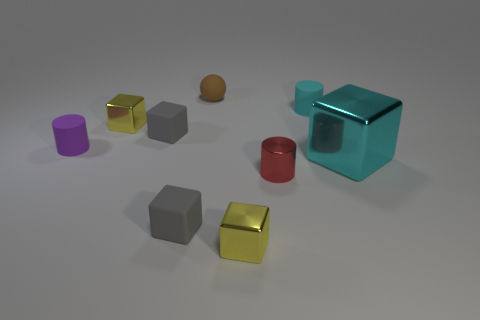Subtract all cyan blocks. How many blocks are left? 4 Subtract all cyan cubes. How many cubes are left? 4 Subtract all blue cubes. Subtract all yellow spheres. How many cubes are left? 5 Add 1 small green metallic things. How many objects exist? 10 Subtract all balls. How many objects are left? 8 Subtract 0 blue spheres. How many objects are left? 9 Subtract all small brown matte things. Subtract all metallic objects. How many objects are left? 4 Add 5 red cylinders. How many red cylinders are left? 6 Add 9 small matte balls. How many small matte balls exist? 10 